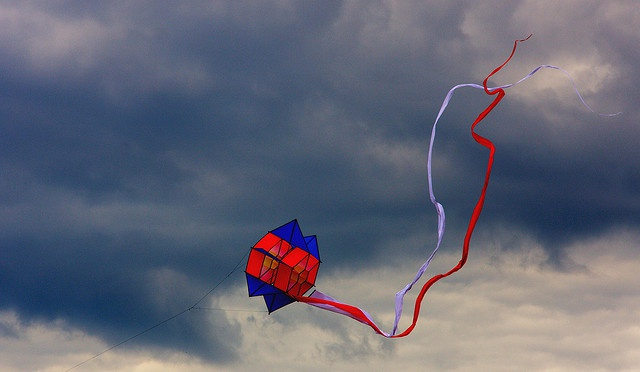Describe the objects in this image and their specific colors. I can see a kite in gray, red, brown, black, and darkblue tones in this image. 